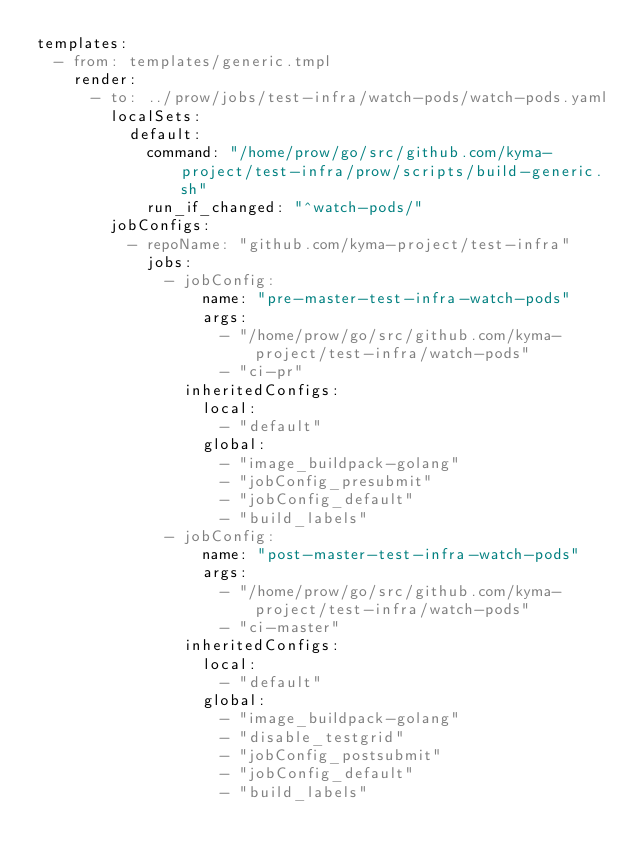<code> <loc_0><loc_0><loc_500><loc_500><_YAML_>templates:
  - from: templates/generic.tmpl
    render:
      - to: ../prow/jobs/test-infra/watch-pods/watch-pods.yaml
        localSets:
          default:
            command: "/home/prow/go/src/github.com/kyma-project/test-infra/prow/scripts/build-generic.sh"
            run_if_changed: "^watch-pods/"
        jobConfigs:
          - repoName: "github.com/kyma-project/test-infra"
            jobs:
              - jobConfig:
                  name: "pre-master-test-infra-watch-pods"
                  args:
                    - "/home/prow/go/src/github.com/kyma-project/test-infra/watch-pods"
                    - "ci-pr"
                inheritedConfigs:
                  local:
                    - "default"
                  global:
                    - "image_buildpack-golang"
                    - "jobConfig_presubmit"
                    - "jobConfig_default"
                    - "build_labels"
              - jobConfig:
                  name: "post-master-test-infra-watch-pods"
                  args:
                    - "/home/prow/go/src/github.com/kyma-project/test-infra/watch-pods"
                    - "ci-master"
                inheritedConfigs:
                  local:
                    - "default"
                  global:
                    - "image_buildpack-golang"
                    - "disable_testgrid"
                    - "jobConfig_postsubmit"
                    - "jobConfig_default"
                    - "build_labels"
</code> 